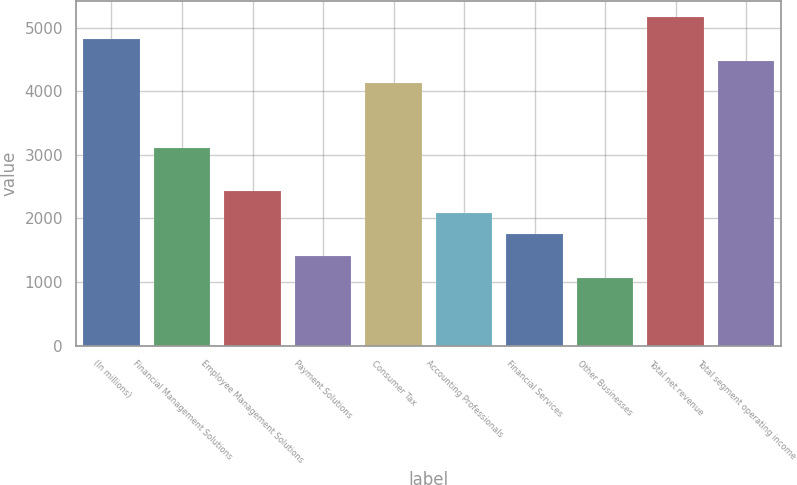Convert chart to OTSL. <chart><loc_0><loc_0><loc_500><loc_500><bar_chart><fcel>(In millions)<fcel>Financial Management Solutions<fcel>Employee Management Solutions<fcel>Payment Solutions<fcel>Consumer Tax<fcel>Accounting Professionals<fcel>Financial Services<fcel>Other Businesses<fcel>Total net revenue<fcel>Total segment operating income<nl><fcel>4820.2<fcel>3113.7<fcel>2431.1<fcel>1407.2<fcel>4137.6<fcel>2089.8<fcel>1748.5<fcel>1065.9<fcel>5161.5<fcel>4478.9<nl></chart> 